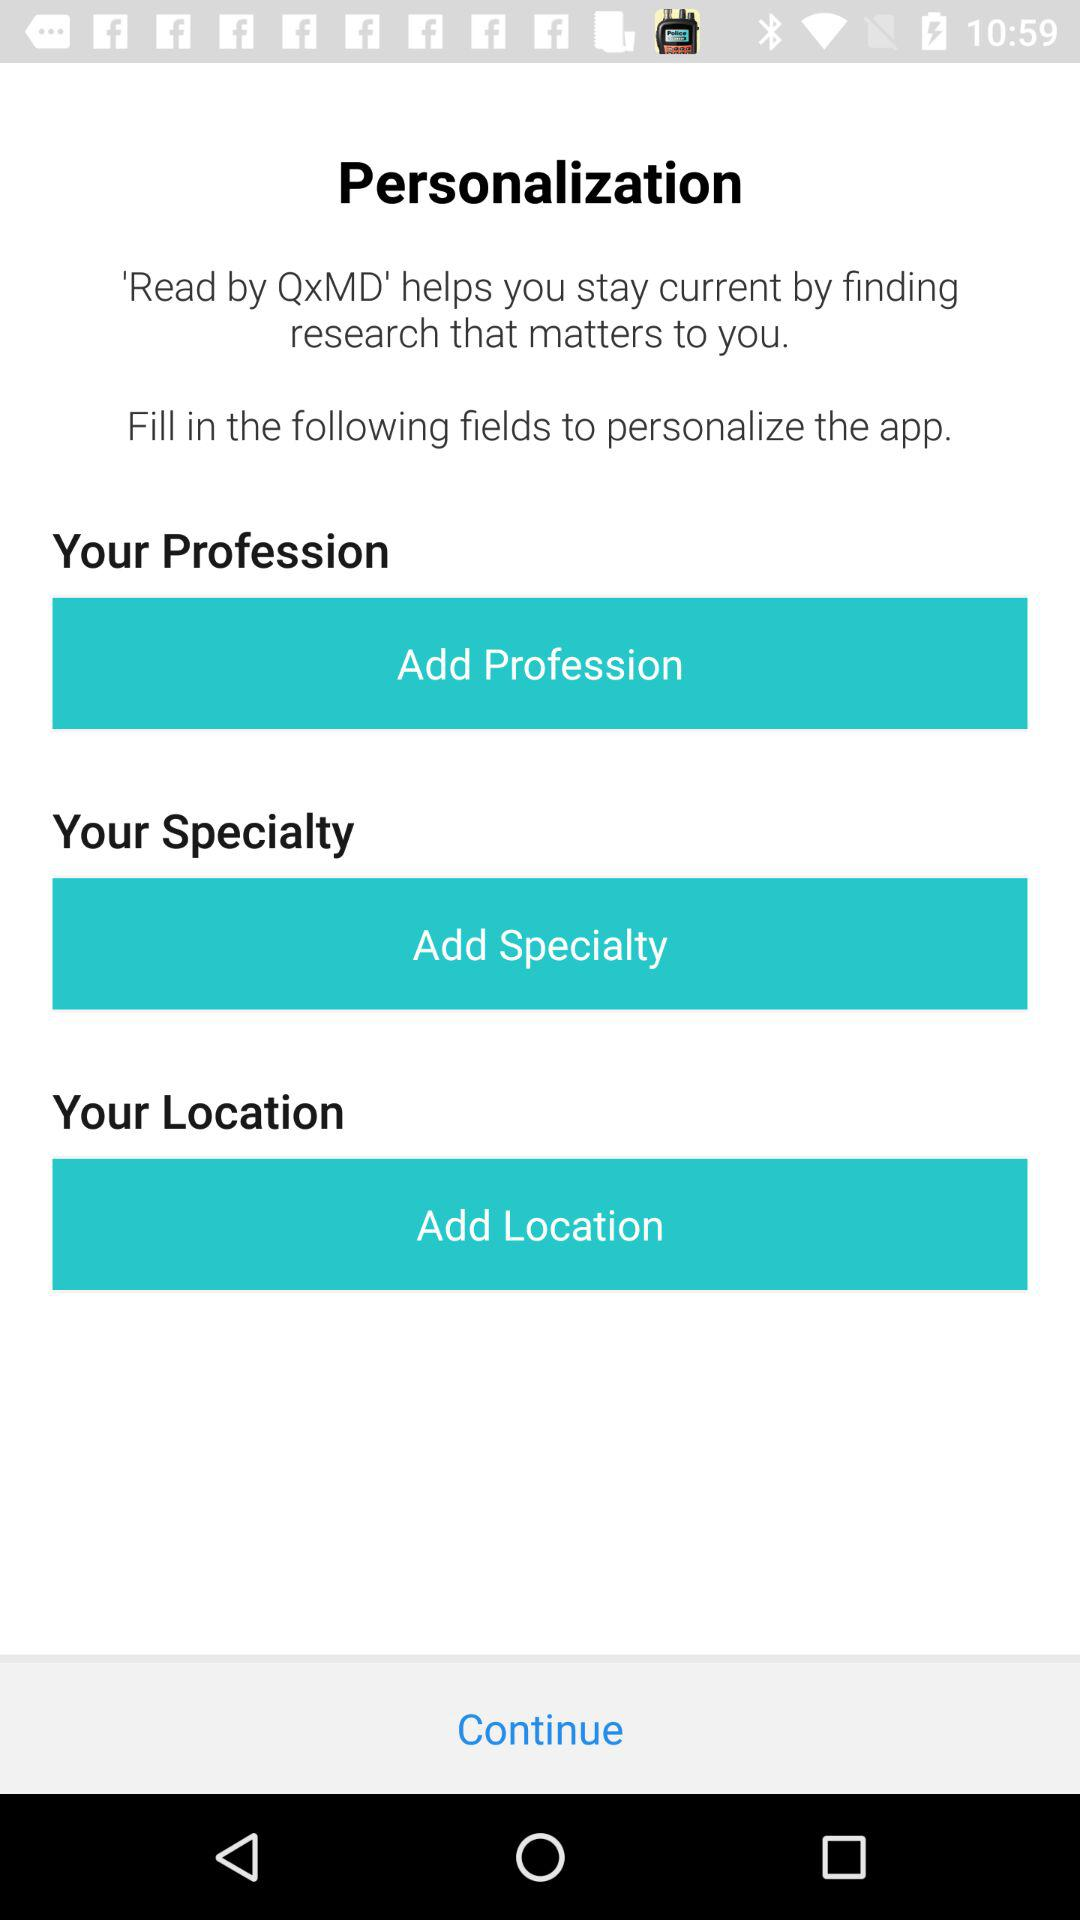How many fields are there to complete to personalize the app?
Answer the question using a single word or phrase. 3 